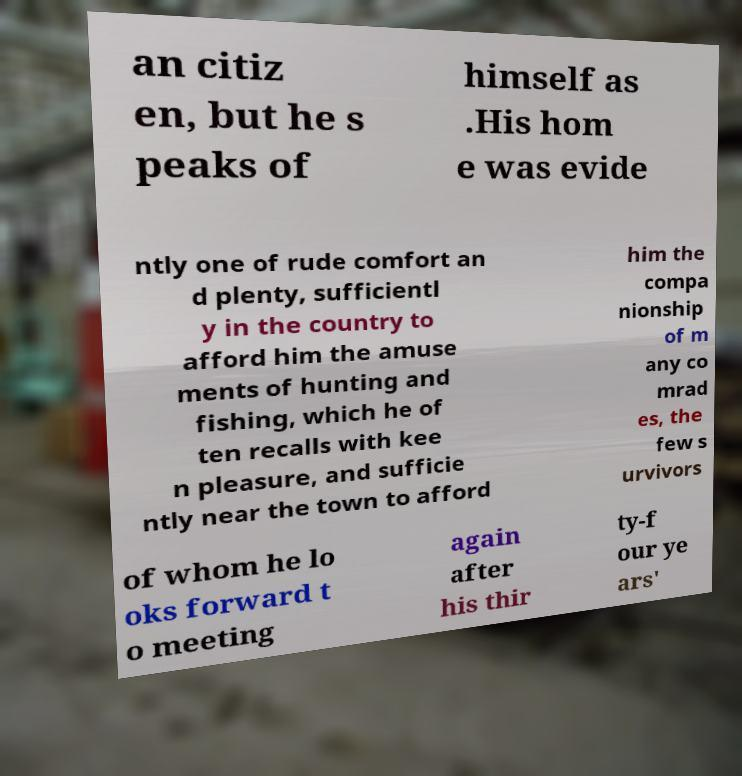There's text embedded in this image that I need extracted. Can you transcribe it verbatim? an citiz en, but he s peaks of himself as .His hom e was evide ntly one of rude comfort an d plenty, sufficientl y in the country to afford him the amuse ments of hunting and fishing, which he of ten recalls with kee n pleasure, and sufficie ntly near the town to afford him the compa nionship of m any co mrad es, the few s urvivors of whom he lo oks forward t o meeting again after his thir ty-f our ye ars' 